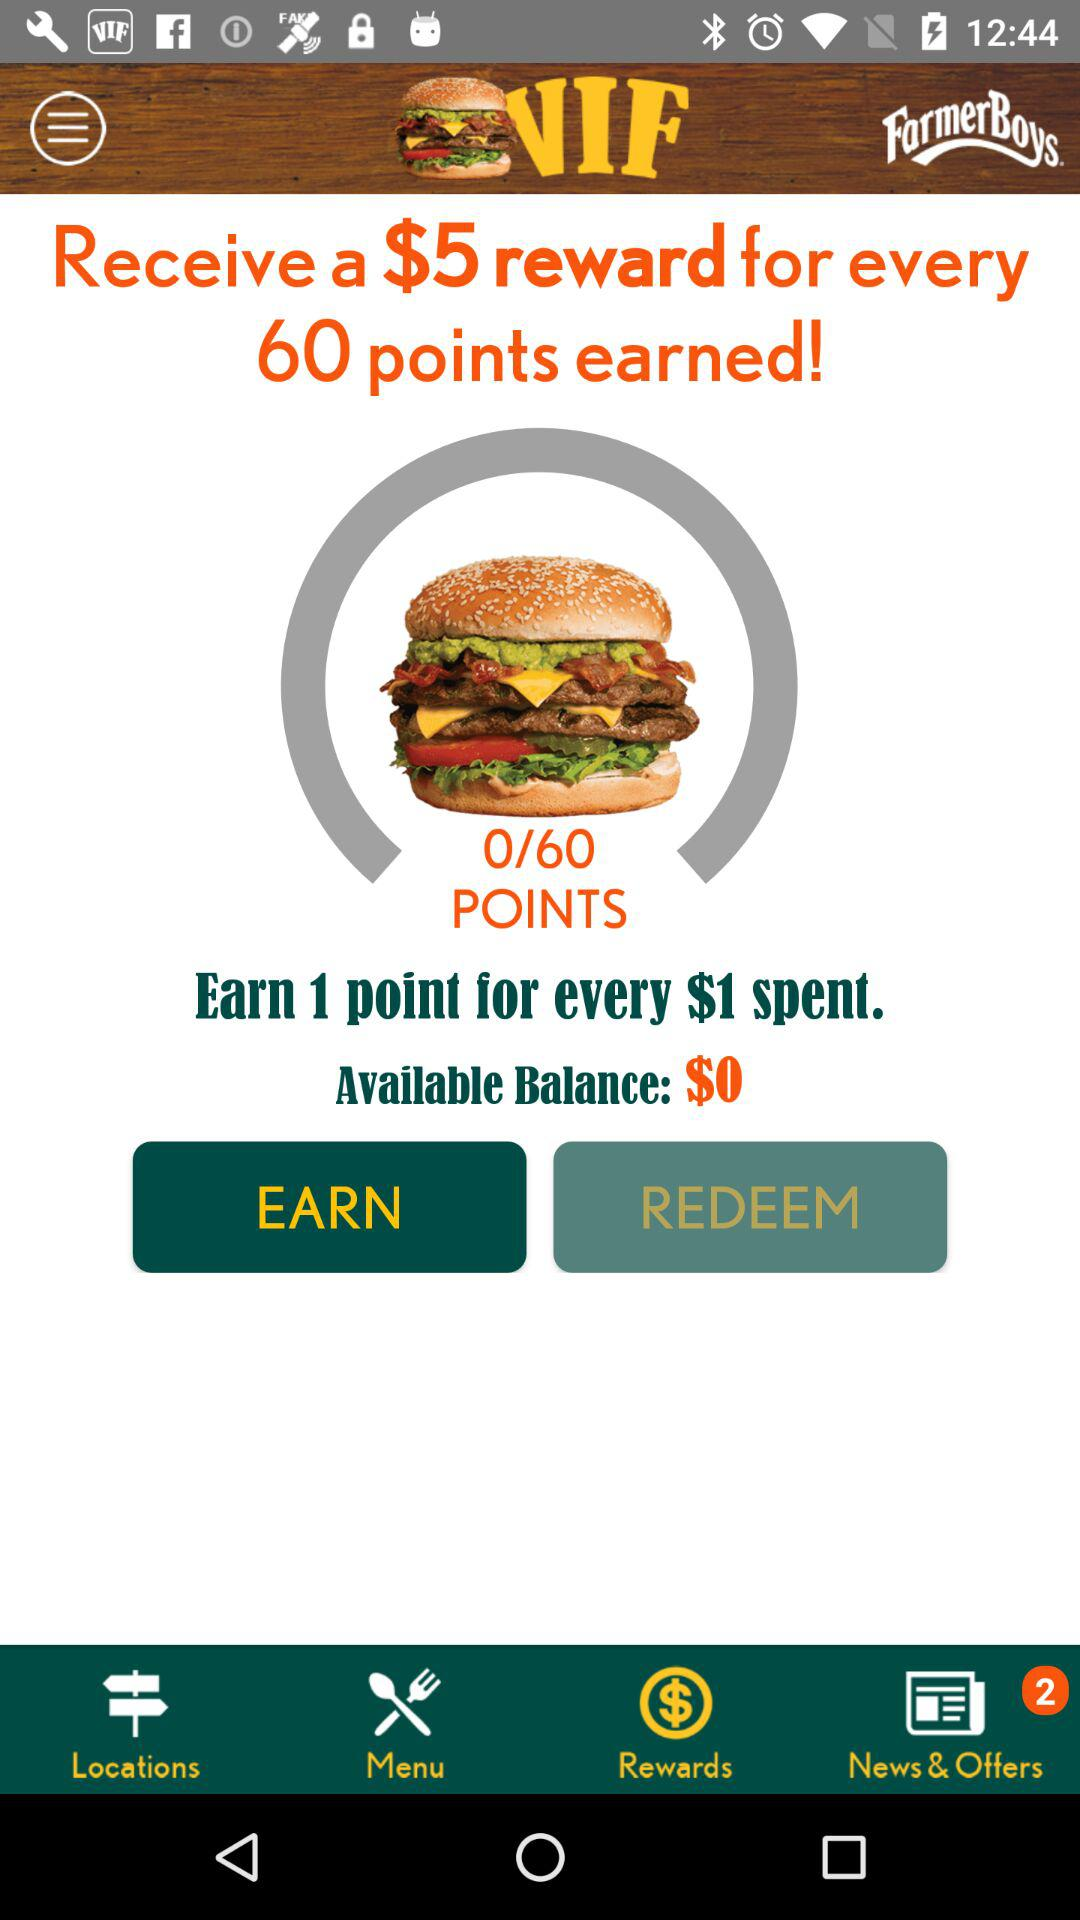How many unread notifications are there for "News & Offers"? There are 2 unread notifications. 